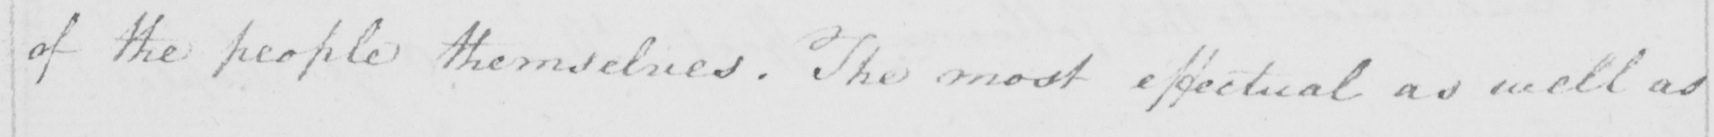Can you read and transcribe this handwriting? of people themselves . The most effectual as well as 